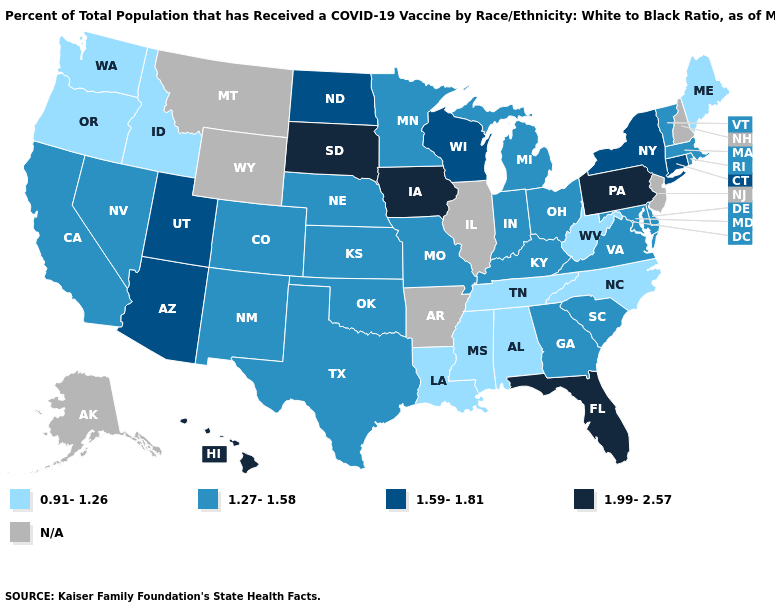Does Pennsylvania have the highest value in the USA?
Be succinct. Yes. Does Rhode Island have the highest value in the Northeast?
Concise answer only. No. Does Maine have the lowest value in the Northeast?
Quick response, please. Yes. Does New Mexico have the highest value in the USA?
Concise answer only. No. Does South Dakota have the lowest value in the MidWest?
Concise answer only. No. What is the value of Kentucky?
Write a very short answer. 1.27-1.58. What is the value of Indiana?
Give a very brief answer. 1.27-1.58. What is the value of Oklahoma?
Answer briefly. 1.27-1.58. How many symbols are there in the legend?
Short answer required. 5. Name the states that have a value in the range 0.91-1.26?
Answer briefly. Alabama, Idaho, Louisiana, Maine, Mississippi, North Carolina, Oregon, Tennessee, Washington, West Virginia. What is the value of Nevada?
Give a very brief answer. 1.27-1.58. What is the lowest value in the West?
Give a very brief answer. 0.91-1.26. What is the highest value in states that border Delaware?
Be succinct. 1.99-2.57. What is the highest value in states that border Washington?
Keep it brief. 0.91-1.26. 